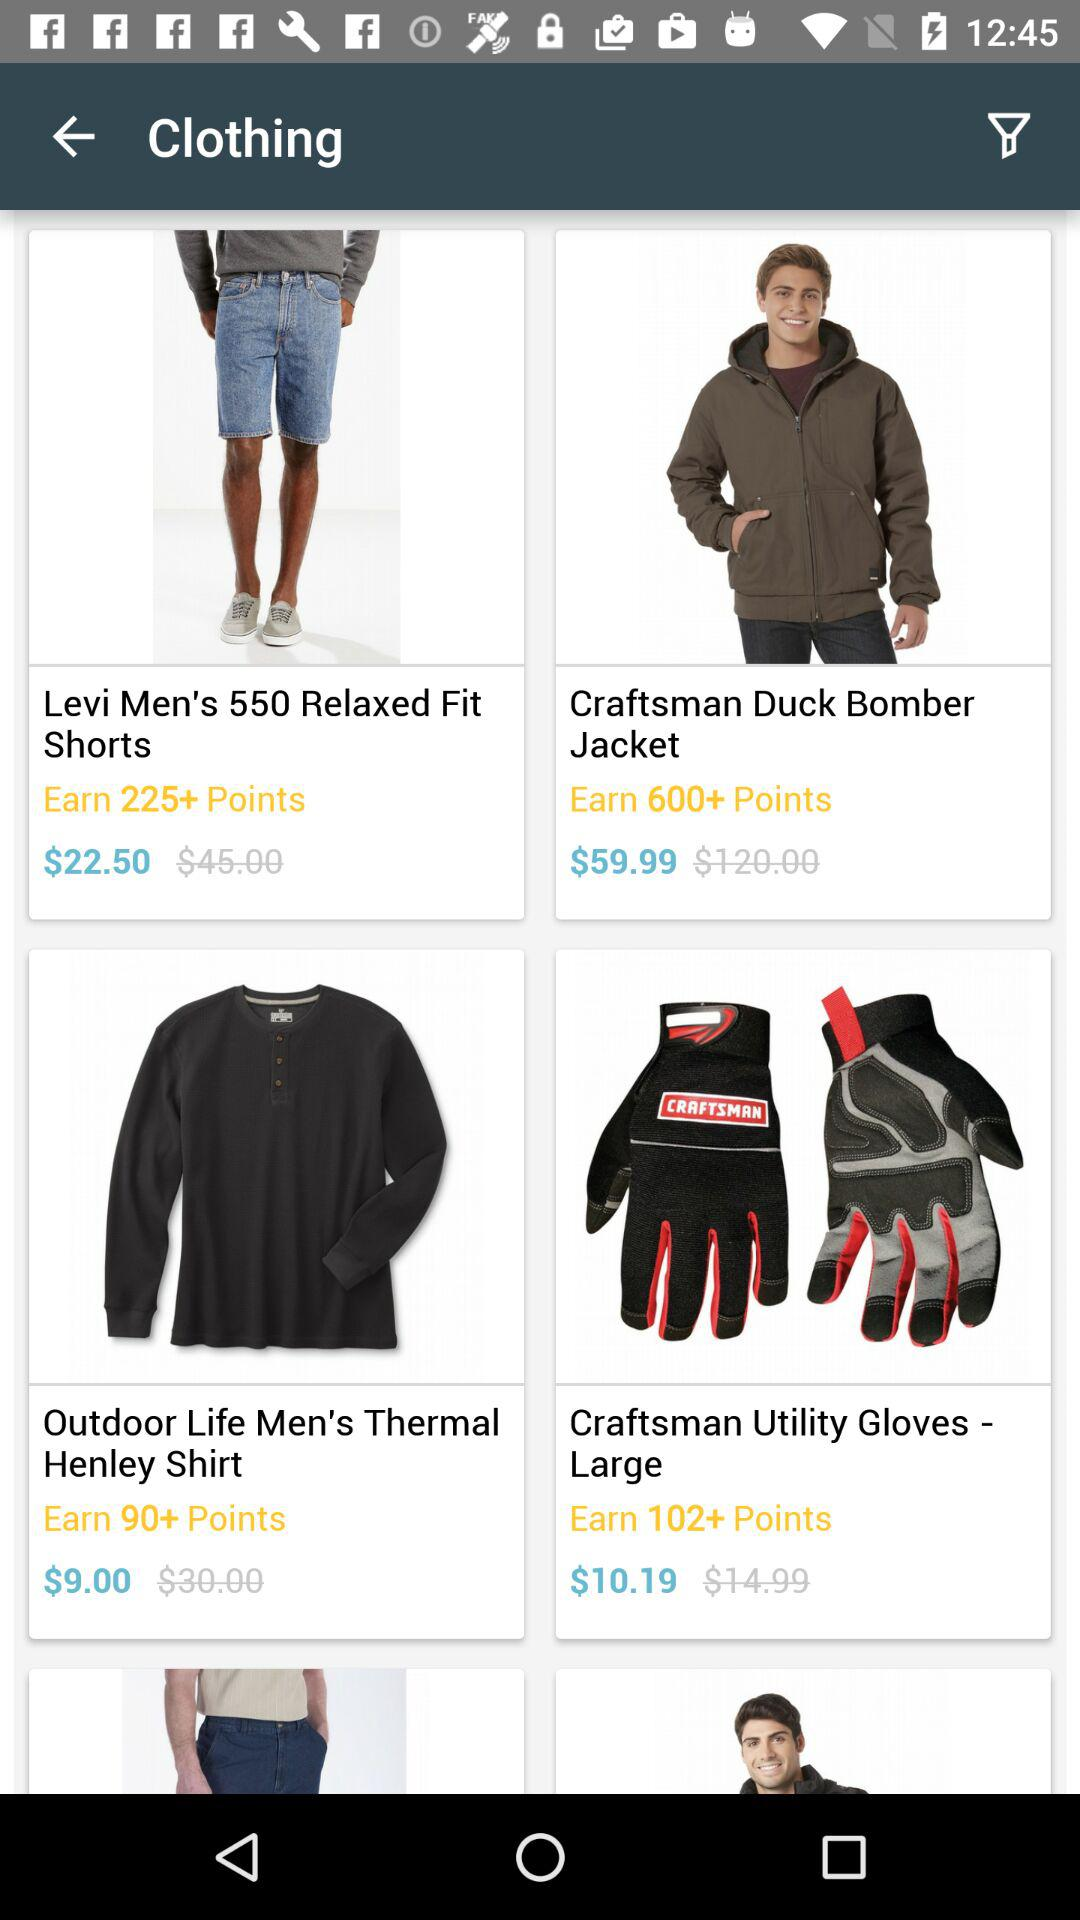Which item has a price of $9.00? The item that has a price of $9.00 is "Outdoor Life Men's Thermal Henley Shirt". 